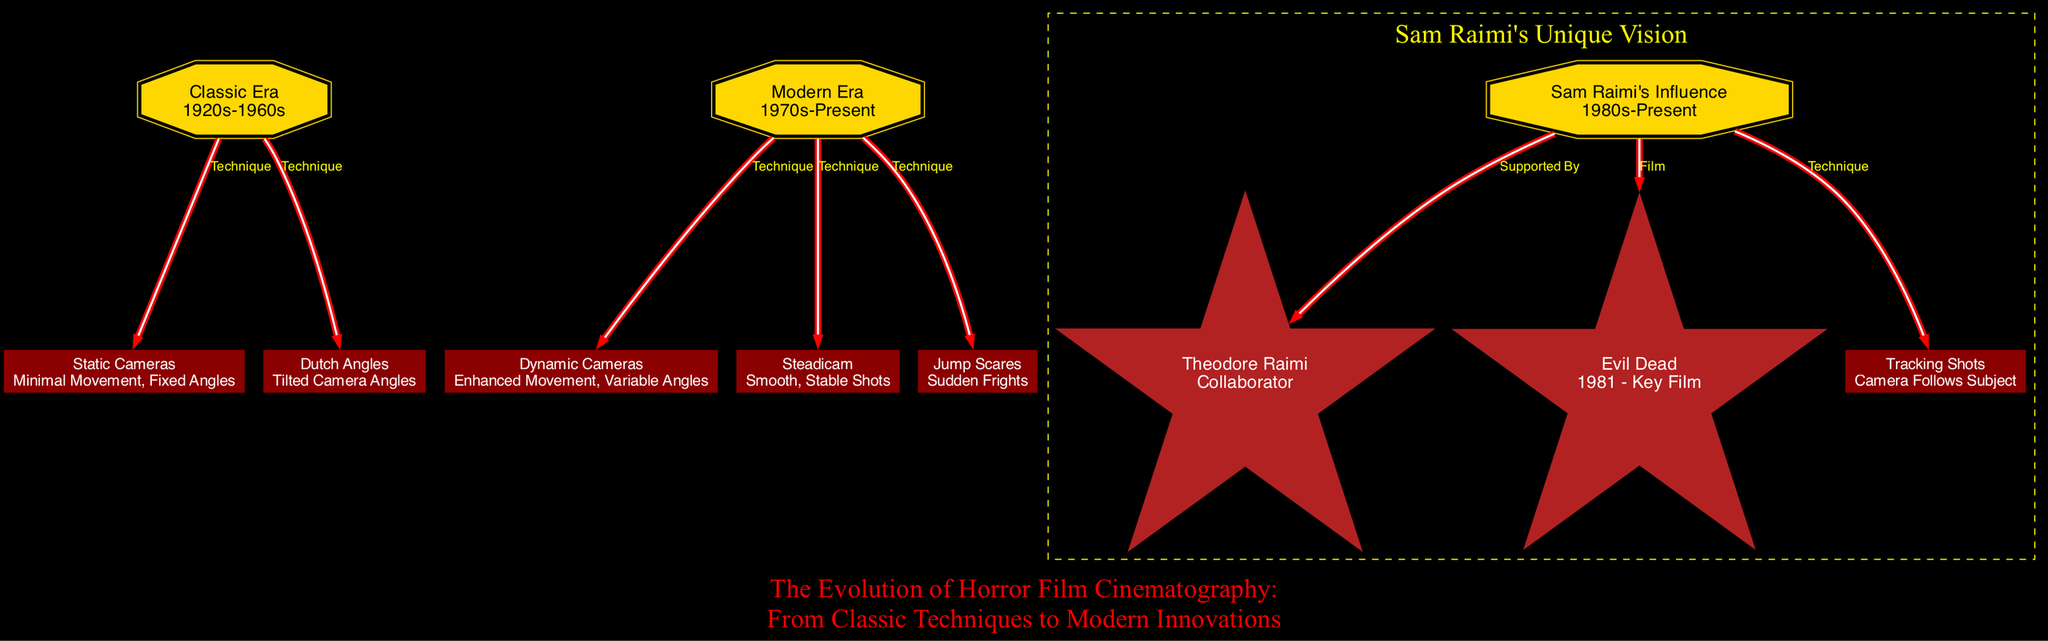What is the time period of the Classic Era? The diagram specifies that the Classic Era lasts from the 1920s to 1960s. To find the answer, we refer to the "Classic Era" node, which provides its description directly.
Answer: 1920s-1960s How many techniques are listed under the Modern Era? There are three techniques listed under the Modern Era in the diagram: dynamic cameras, jump scares, and steadicam. By counting the outgoing edges from the "modernEra" node, we find the total is three.
Answer: 3 What technique is associated with Sam Raimi's influence? The diagram indicates that tracking shots are linked to Sam Raimi's influence. We look at the connections from the "raimiInfluence" node to identify the technique.
Answer: Tracking Shots Which film is specifically listed under Sam Raimi's influence? The diagram highlights "Evil Dead" as a key film associated with Sam Raimi's influence. This information can be found directly from the edge connecting "raimiInfluence" to "evilDead."
Answer: Evil Dead Which camera technique is characterized by enhanced movement and variable angles? The technique relating to enhanced movement and variable angles is termed dynamic cameras. We check the definition given for the "dynamicCameras" node for clarification.
Answer: Dynamic Cameras What is the relationship between the Classic Era and Dutch Angles? The diagram shows a direct relationship labeled "Technique" from the Classic Era to Dutch Angles. This connection indicates that Dutch Angles are a technique used in that era.
Answer: Technique Which collaborator is mentioned in relation to Sam Raimi? Theodore Raimi is identified as a collaborator connected to Sam Raimi's influence. We refer to the outgoing edge from the "raimiInfluence" node to determine this.
Answer: Theodore Raimi What type of angles does the term Dutch Angles refer to? Dutch Angles refer to tilted camera angles, as defined in the diagram. To answer this, we refer specifically to the "dutchAngles" node for its description.
Answer: Tilted Camera Angles How many nodes are associated with the Modern Era? The Modern Era is connected to four nodes according to the diagram: dynamic cameras, jump scares, steadicam, and modernEra itself. We count the edges from "modernEra" to find the answer.
Answer: 4 